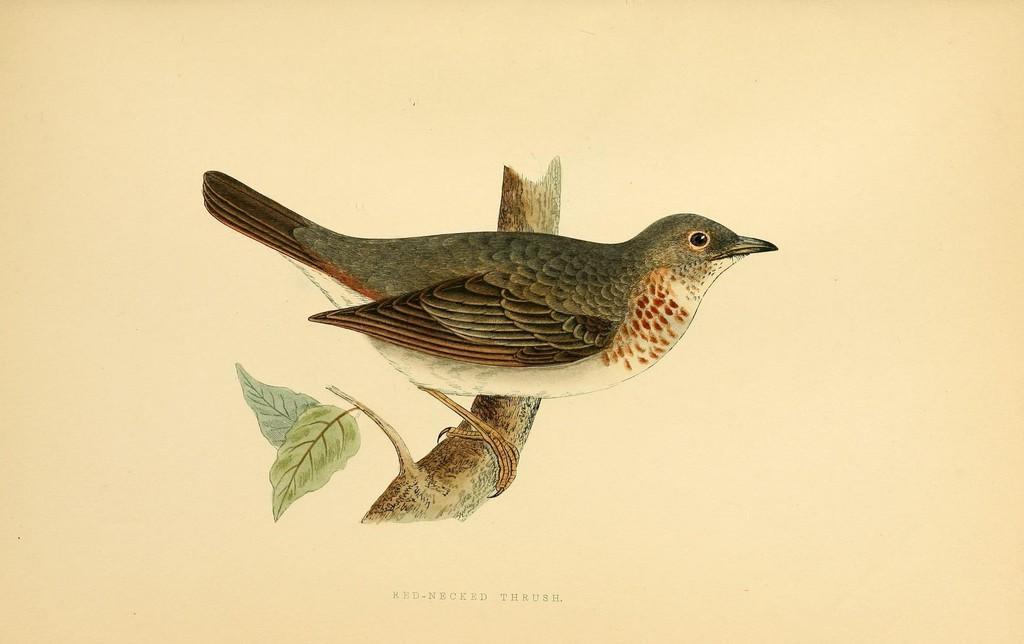Could you give a brief overview of what you see in this image? This is a poster. In the center of the image we can see a bird is present on a stem and also we can see the leaves. At the bottom of the image we can see the text. 